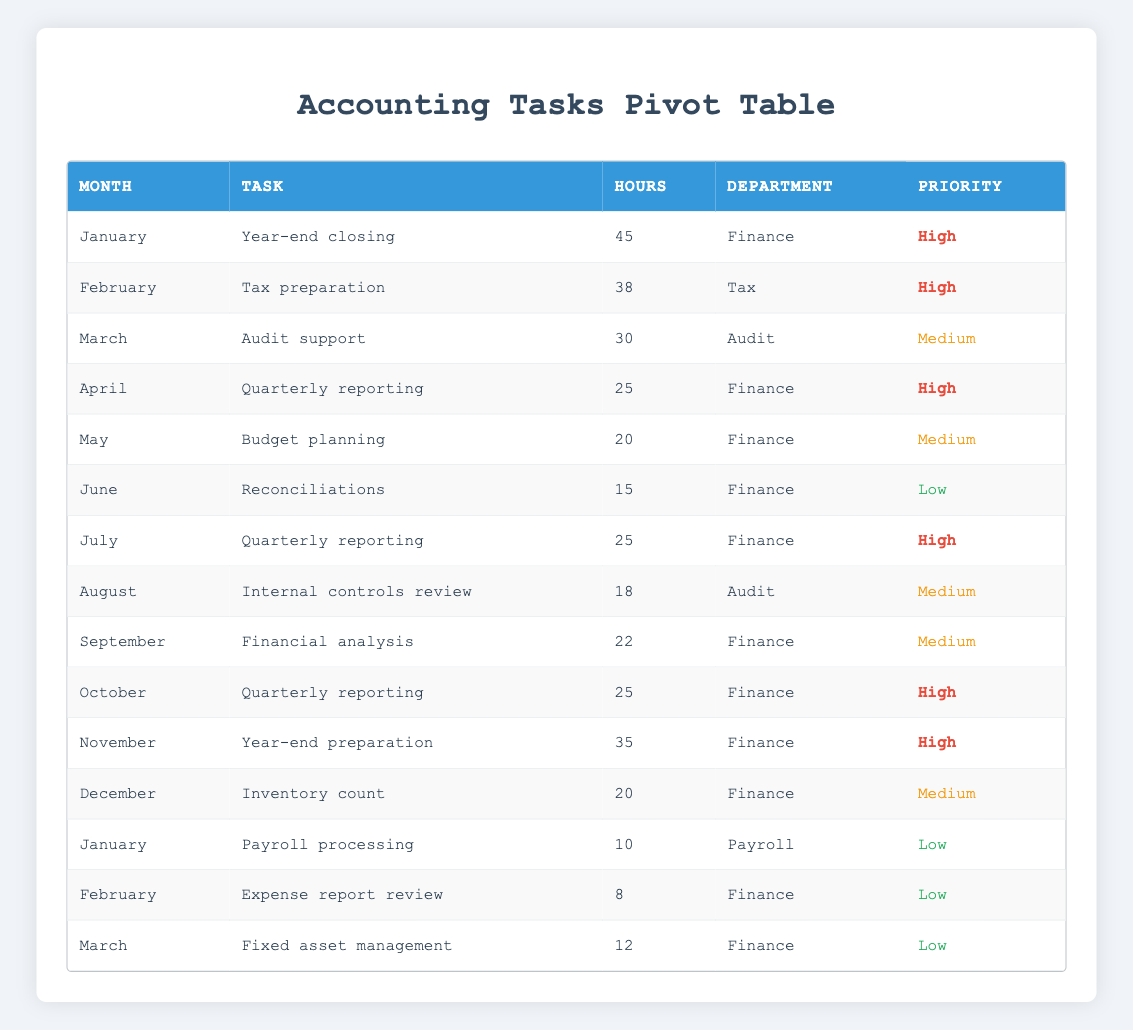what is the total number of hours spent on 'Quarterly reporting'? To find this, we look for all occurrences of 'Quarterly reporting' in the table. It appears in April, July, and October with hours of 25, 25, and 25 respectively. Adding these gives us a total of 25 + 25 + 25 = 75 hours.
Answer: 75 which month has the highest number of hours dedicated to 'Year-end preparation'? The task 'Year-end preparation' only appears in November with 35 hours. Since it's the only month listed for this task, it naturally has the highest number of hours.
Answer: November what is the average time spent on tasks labeled as 'High' priority? We need to identify all tasks with 'High' priority. Those are: Year-end closing (45), Tax preparation (38), Quarterly reporting (25), Quarterly reporting (25), Quarterly reporting (25), Year-end preparation (35). Adding these gives 45 + 38 + 25 + 25 + 25 + 35 = 193 hours. To find the average, we divide by the count of tasks, which is 6, leading to an average of 193/6 = ~32.17 hours.
Answer: 32.17 is there a month when 'Payroll processing' is the highest priority task? The table shows 'Payroll processing' listed under January with a priority of 'Low'. There are no entries in the table for 'Payroll processing' that have 'High' priority, indicating this statement is false.
Answer: No how many different tasks were recorded for the Finance department? Going through the table, we find the tasks for the Finance department: Year-end closing, Quarterly reporting (three times), Budget planning, Reconciliations, Financial analysis, Year-end preparation, and Expense report review (from Payroll). Counting these distinct tasks gives us 7 different tasks.
Answer: 7 which month requires the least number of hours for 'Reconciliations'? The task 'Reconciliations' appears only once in June, where it took 15 hours. Since it's the only entry for this task, it represents the least number of hours.
Answer: June what is the total number of hours spent in March, and how does that compare to the total hours spent in April? In March, the tasks are Audit support (30) and Fixed asset management (12), giving a total of 30 + 12 = 42 hours. In April, the total hours for Quarterly reporting is 25 hours. Comparing these shows that March had more hours than April (42 > 25).
Answer: 42 hours in March; more than April are there any months where the total hours for 'Medium' priority tasks exceed those of 'Low' priority tasks? To determine this, we sum the hours for 'Medium' priorities: Audit support (30), Budget planning (20), Internal controls review (18), Financial analysis (22), and Year-end preparation (35), which totals to 125 hours. For 'Low' priority tasks: Reconciliations (15), Payroll processing (10), and Expense report review (8) amounts to 33 hours. Since 125 > 33, the answer is yes.
Answer: Yes 